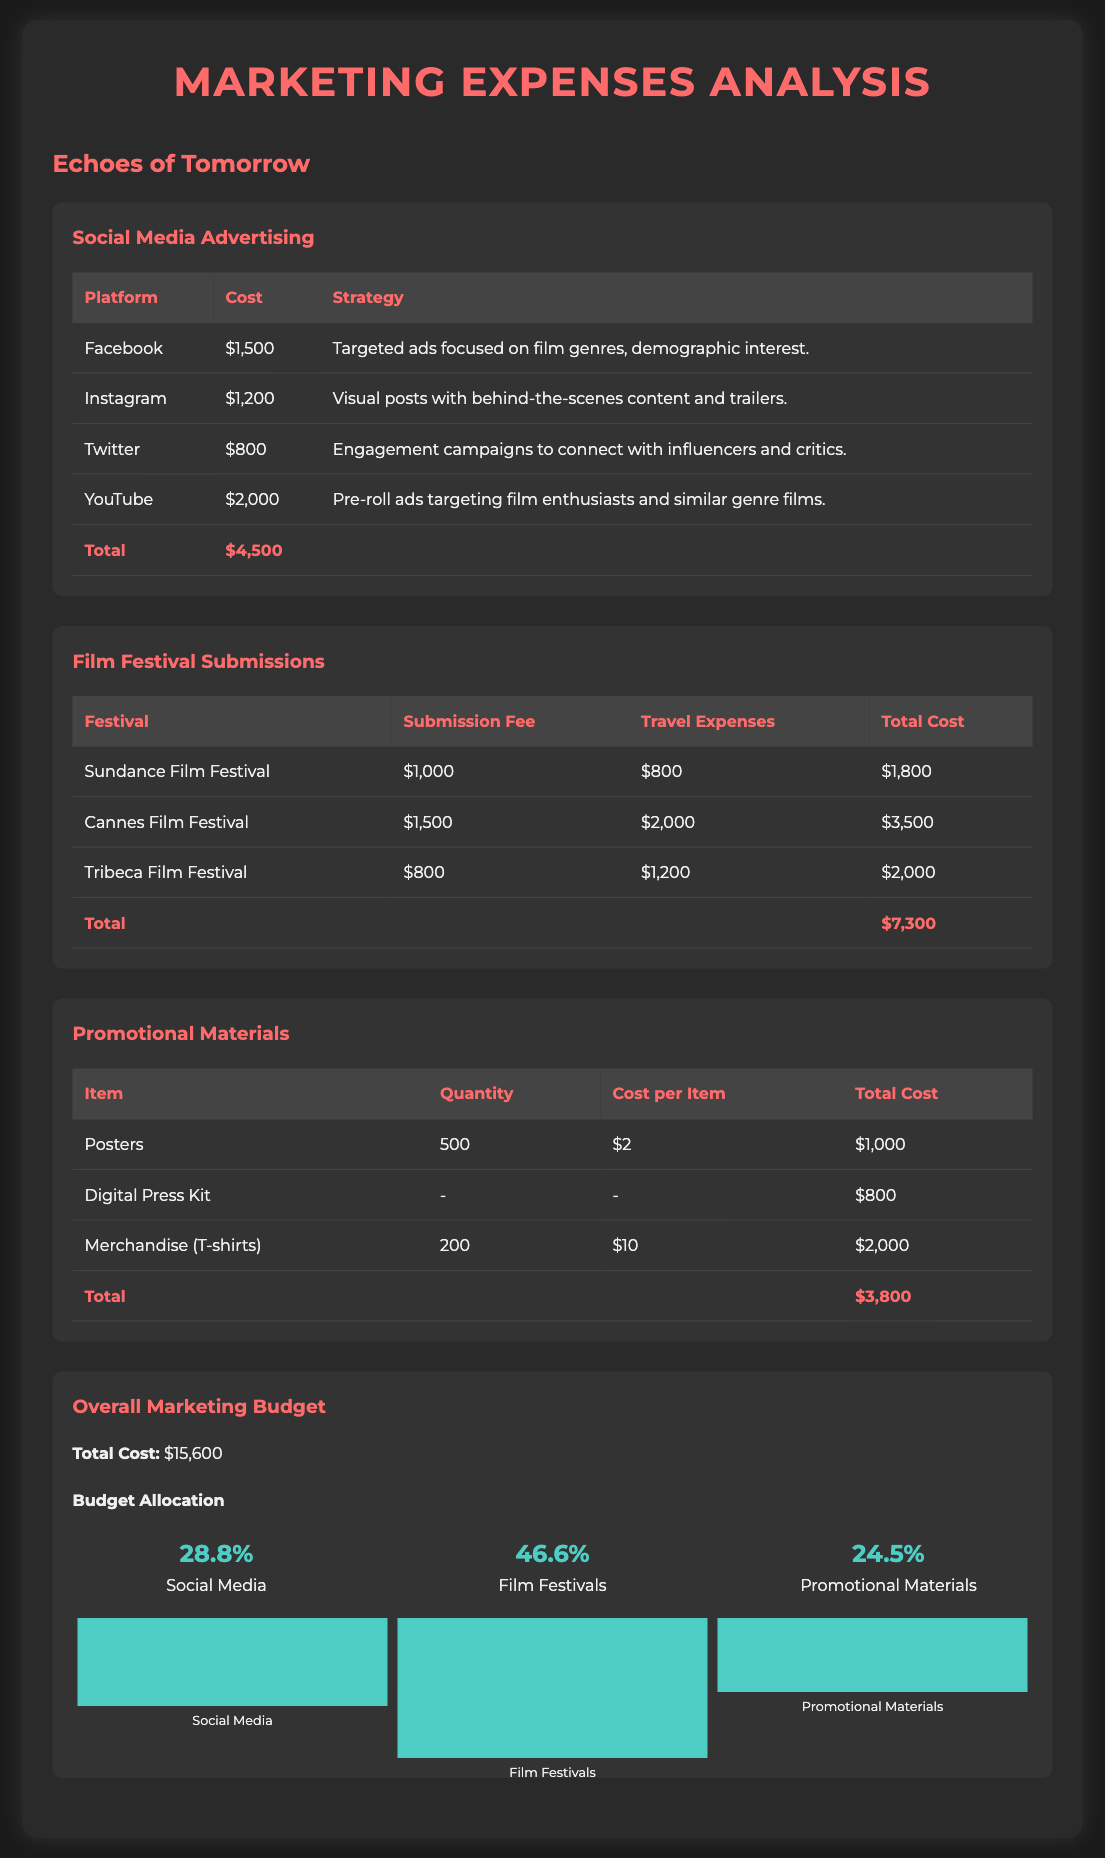What is the total cost for social media advertising? The total cost for social media advertising is highlighted in the document as a separate category, totaling $4,500.
Answer: $4,500 What is the cost for the Cannes Film Festival submission? The cost for the Cannes Film Festival submission is detailed in the table that lists both the submission fee and travel expenses for the festival. The total cost is $3,500.
Answer: $3,500 How much was spent on promotional materials? The total expenditure on promotional materials is given at the end of that section in the document and amounts to $3,800.
Answer: $3,800 What percentage of the total marketing budget was allocated to film festivals? The percentage allocated to film festivals is provided in the budget allocation section, stating 46.6%.
Answer: 46.6% Which social media platform had the highest advertising cost? The document lists the advertising costs by platform, indicating that YouTube had the highest cost at $2,000.
Answer: YouTube What are the travel expenses for the Sundance Film Festival? The travel expenses for the Sundance Film Festival are specified separately, which is $800.
Answer: $800 What is the total marketing budget? The total marketing budget is provided at the end of the budget section, amounting to $15,600.
Answer: $15,600 How many posters were printed for promotional materials? The document specifies that 500 posters were printed, which is listed in the promotional materials section.
Answer: 500 What marketing strategy was used for Instagram? The document describes the Instagram strategy as visual posts with behind-the-scenes content and trailers, providing specific context for its use.
Answer: Visual posts with behind-the-scenes content and trailers 